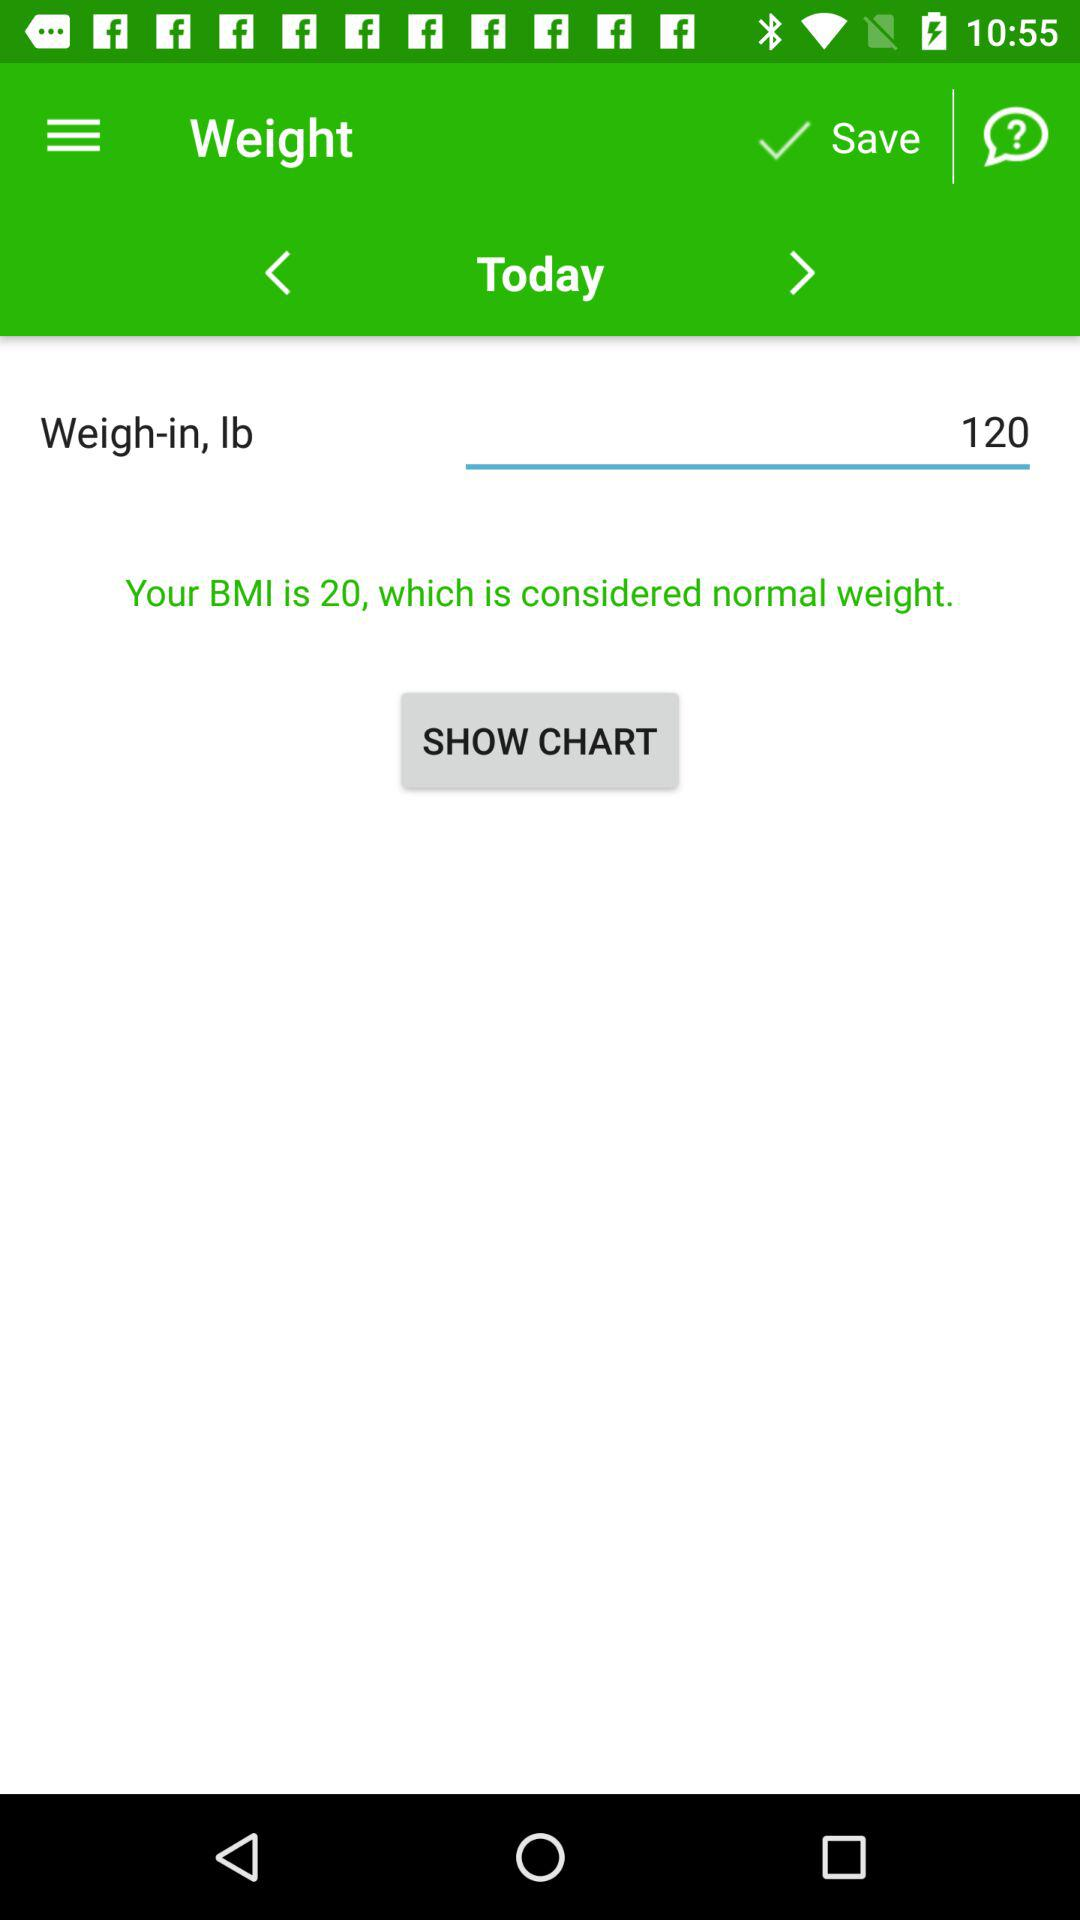What bmi is considered as normal weight?
When the provided information is insufficient, respond with <no answer>. <no answer> 